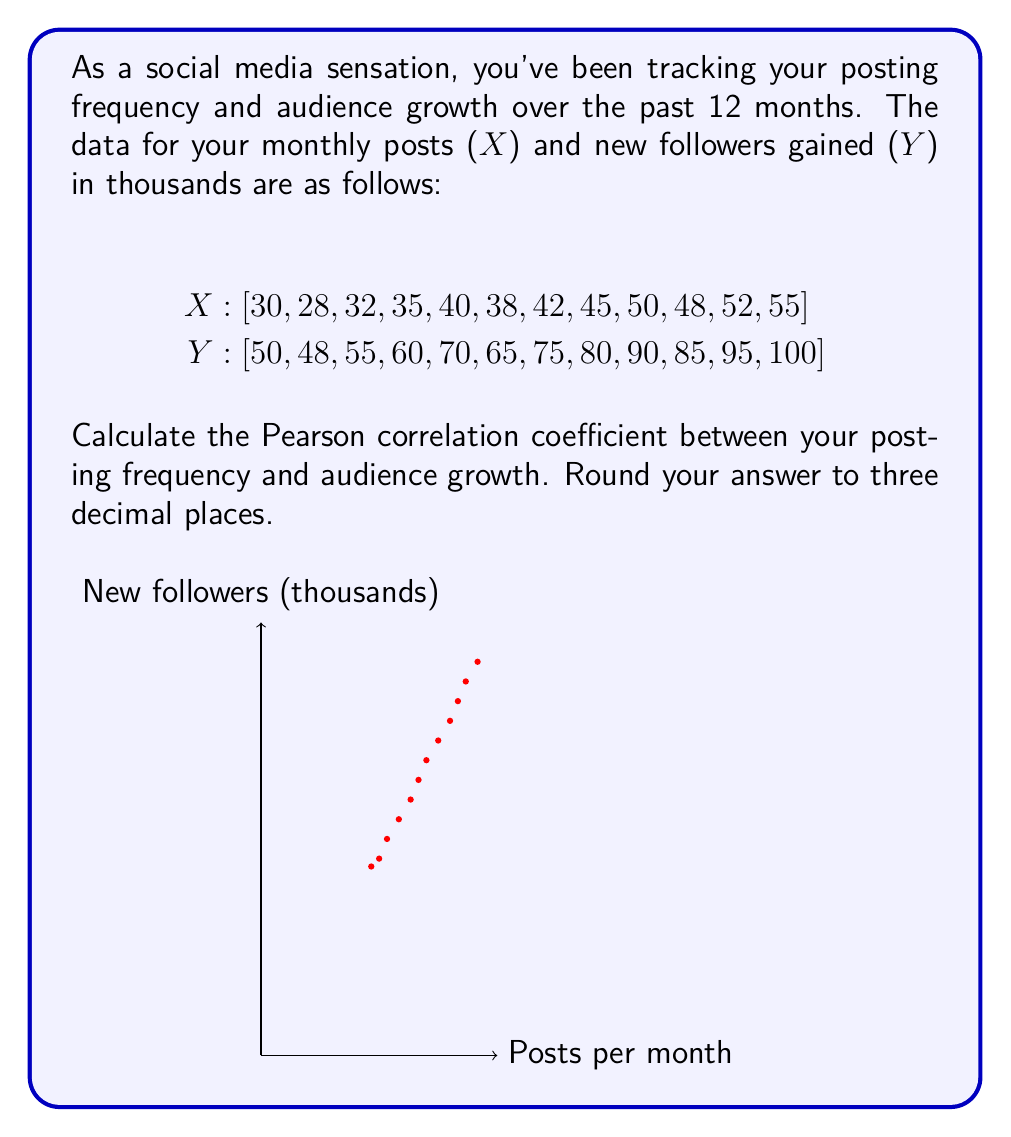Help me with this question. To calculate the Pearson correlation coefficient (r), we'll use the formula:

$$ r = \frac{\sum_{i=1}^{n} (x_i - \bar{x})(y_i - \bar{y})}{\sqrt{\sum_{i=1}^{n} (x_i - \bar{x})^2 \sum_{i=1}^{n} (y_i - \bar{y})^2}} $$

Step 1: Calculate the means $\bar{x}$ and $\bar{y}$
$\bar{x} = \frac{\sum_{i=1}^{n} x_i}{n} = \frac{495}{12} = 41.25$
$\bar{y} = \frac{\sum_{i=1}^{n} y_i}{n} = \frac{873}{12} = 72.75$

Step 2: Calculate $(x_i - \bar{x})$, $(y_i - \bar{y})$, $(x_i - \bar{x})^2$, $(y_i - \bar{y})^2$, and $(x_i - \bar{x})(y_i - \bar{y})$ for each data point.

Step 3: Sum up the results from Step 2:
$\sum (x_i - \bar{x})(y_i - \bar{y}) = 1833.75$
$\sum (x_i - \bar{x})^2 = 1024.75$
$\sum (y_i - \bar{y})^2 = 3384.75$

Step 4: Apply the formula:

$$ r = \frac{1833.75}{\sqrt{1024.75 \times 3384.75}} = 0.98847... $$

Step 5: Round to three decimal places: 0.988
Answer: 0.988 